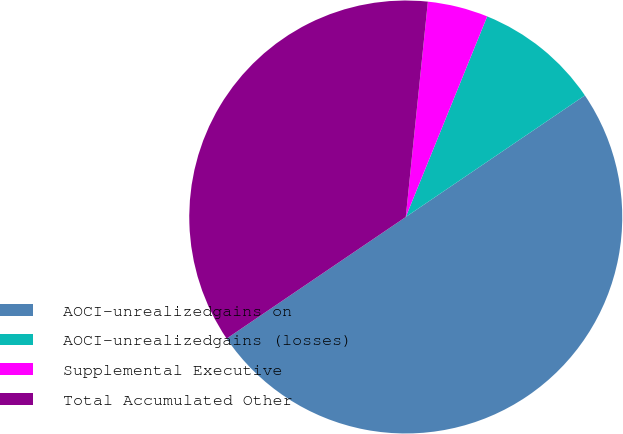Convert chart to OTSL. <chart><loc_0><loc_0><loc_500><loc_500><pie_chart><fcel>AOCI-unrealizedgains on<fcel>AOCI-unrealizedgains (losses)<fcel>Supplemental Executive<fcel>Total Accumulated Other<nl><fcel>50.0%<fcel>9.37%<fcel>4.51%<fcel>36.12%<nl></chart> 